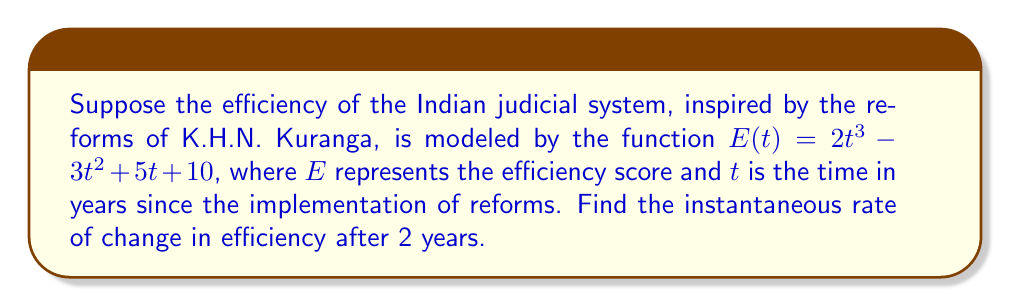What is the answer to this math problem? To find the instantaneous rate of change, we need to calculate the derivative of the function $E(t)$ and then evaluate it at $t=2$.

Step 1: Find the derivative of $E(t)$.
$$\frac{d}{dt}E(t) = \frac{d}{dt}(2t^3 - 3t^2 + 5t + 10)$$
$$E'(t) = 6t^2 - 6t + 5$$

Step 2: Evaluate the derivative at $t=2$.
$$E'(2) = 6(2)^2 - 6(2) + 5$$
$$E'(2) = 6(4) - 12 + 5$$
$$E'(2) = 24 - 12 + 5$$
$$E'(2) = 17$$

The instantaneous rate of change is 17 efficiency units per year after 2 years.
Answer: 17 efficiency units/year 